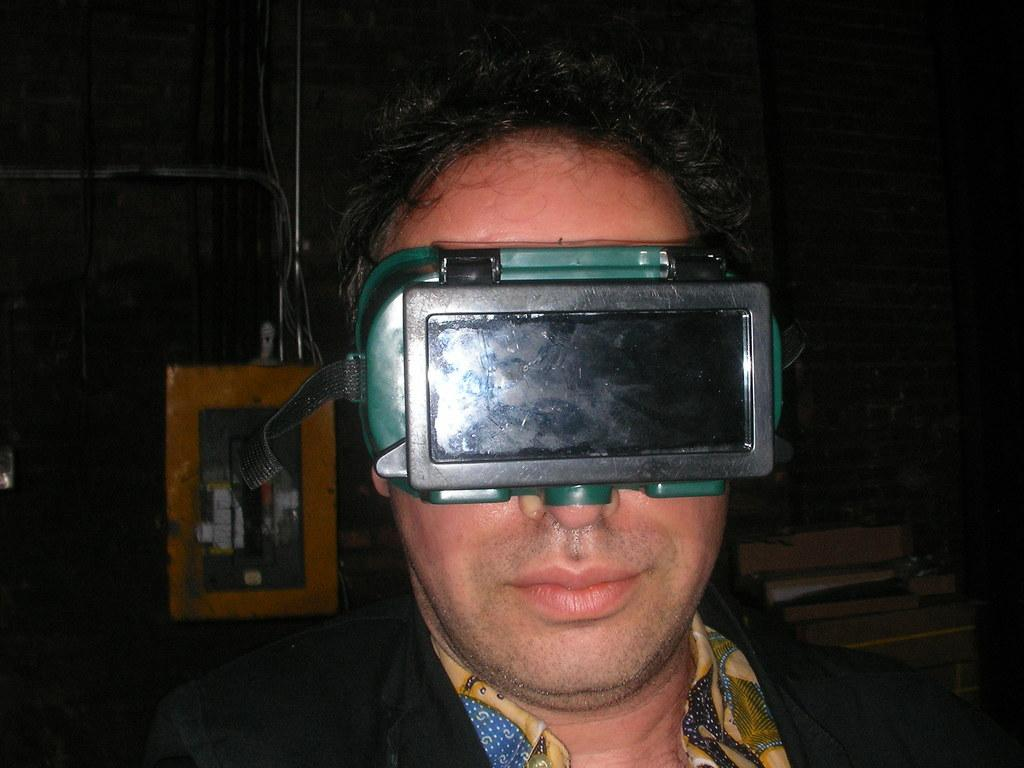What is the main subject of the image? There is a person in the image. What is the person wearing? The person is wearing a blazer. What activity is the person engaged in? The person is using virtual reality. How would you describe the background of the image? The background of the image is dark. How many ladybugs can be seen crawling on the person's blazer in the image? There are no ladybugs present on the person's blazer in the image. What type of coal is being used to fuel the virtual reality device in the image? There is no coal present in the image, and the virtual reality device does not require coal for fuel. 